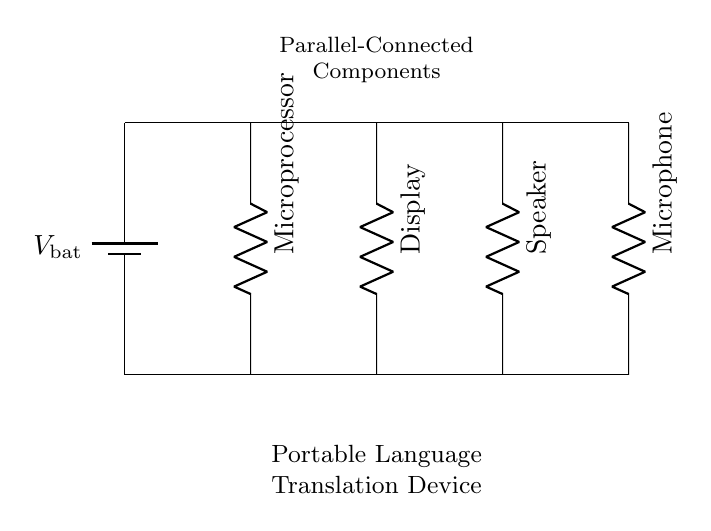What is the total number of components in this circuit? The circuit has four main components: a microprocessor, a display, a speaker, and a microphone. Therefore, simply counting these components gives the total as four.
Answer: Four What type of circuit connection is used in this diagram? The circuit diagram clearly illustrates parallel connections, as each component is connected across the same two voltage rails, allowing them to operate independently.
Answer: Parallel What is the function of the microprocessor in this device? The microprocessor typically serves as the central unit that processes input from the microphone and manages output to the speaker and display, playing a crucial role in language translation.
Answer: Central processing How many outputs are represented in this circuit? There are two output devices shown: the display and the speaker. The output signifies how the device communicates the translated language back to the user.
Answer: Two What is the purpose of the battery in this circuit? The battery provides the necessary power supply for the entire circuit, ensuring that all components operate correctly by delivering the required voltage.
Answer: Power supply If one component fails, how will that affect the other components? In a parallel connection, if one component fails, the other components will continue to operate because they each have their own direct connection to the battery.
Answer: Other components remain functional 